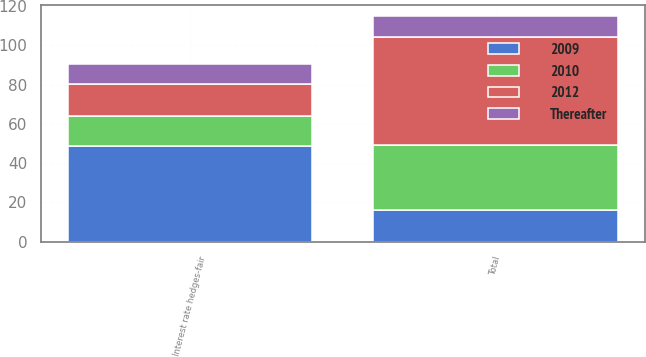<chart> <loc_0><loc_0><loc_500><loc_500><stacked_bar_chart><ecel><fcel>Interest rate hedges-fair<fcel>Total<nl><fcel>2009<fcel>48.9<fcel>16<nl><fcel>2012<fcel>16<fcel>55.3<nl><fcel>2010<fcel>15.2<fcel>33<nl><fcel>Thereafter<fcel>10.6<fcel>10.6<nl></chart> 